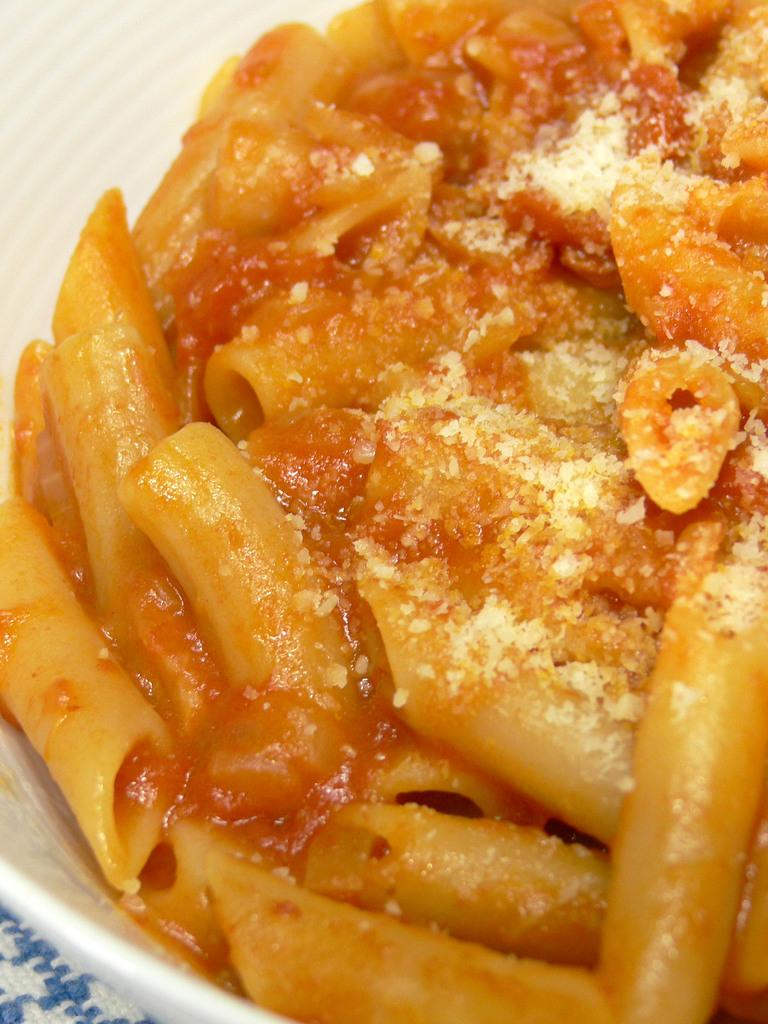What is in the bowl that is visible in the image? There is food in the bowl in the image. Can you describe the appearance of the food? The food has brown and cream colors. What color is the bowl? The bowl is white. How many people are in the cellar in the image? There is no mention of a cellar or any people in the image; it only features a bowl of food with brown and cream colors in a white bowl. 